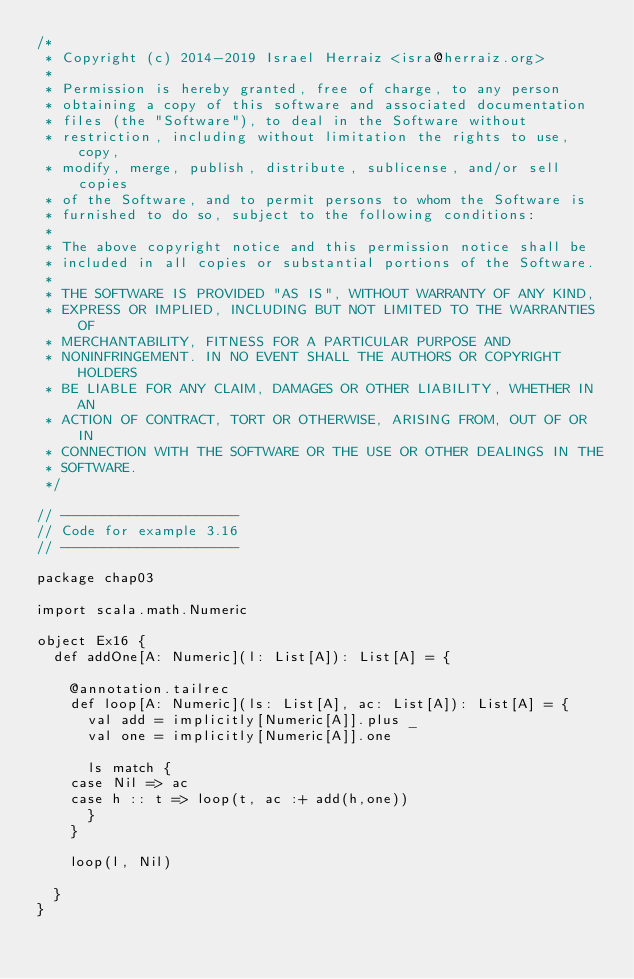Convert code to text. <code><loc_0><loc_0><loc_500><loc_500><_Scala_>/*
 * Copyright (c) 2014-2019 Israel Herraiz <isra@herraiz.org>
 *
 * Permission is hereby granted, free of charge, to any person
 * obtaining a copy of this software and associated documentation
 * files (the "Software"), to deal in the Software without
 * restriction, including without limitation the rights to use, copy,
 * modify, merge, publish, distribute, sublicense, and/or sell copies
 * of the Software, and to permit persons to whom the Software is
 * furnished to do so, subject to the following conditions:
 *
 * The above copyright notice and this permission notice shall be
 * included in all copies or substantial portions of the Software.
 *
 * THE SOFTWARE IS PROVIDED "AS IS", WITHOUT WARRANTY OF ANY KIND,
 * EXPRESS OR IMPLIED, INCLUDING BUT NOT LIMITED TO THE WARRANTIES OF
 * MERCHANTABILITY, FITNESS FOR A PARTICULAR PURPOSE AND
 * NONINFRINGEMENT. IN NO EVENT SHALL THE AUTHORS OR COPYRIGHT HOLDERS
 * BE LIABLE FOR ANY CLAIM, DAMAGES OR OTHER LIABILITY, WHETHER IN AN
 * ACTION OF CONTRACT, TORT OR OTHERWISE, ARISING FROM, OUT OF OR IN
 * CONNECTION WITH THE SOFTWARE OR THE USE OR OTHER DEALINGS IN THE
 * SOFTWARE.
 */  

// ---------------------
// Code for example 3.16
// ---------------------

package chap03

import scala.math.Numeric

object Ex16 {
  def addOne[A: Numeric](l: List[A]): List[A] = {
    
    @annotation.tailrec
    def loop[A: Numeric](ls: List[A], ac: List[A]): List[A] = {
      val add = implicitly[Numeric[A]].plus _
      val one = implicitly[Numeric[A]].one
    
      ls match {
	case Nil => ac
	case h :: t => loop(t, ac :+ add(h,one))
      }
    }

    loop(l, Nil)

  }
}
</code> 